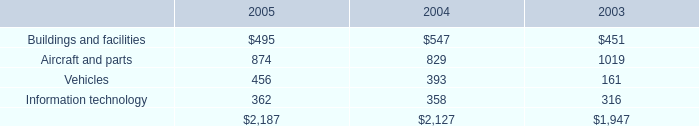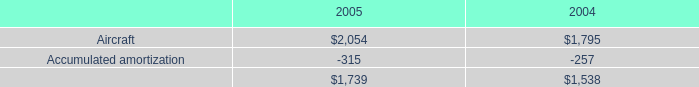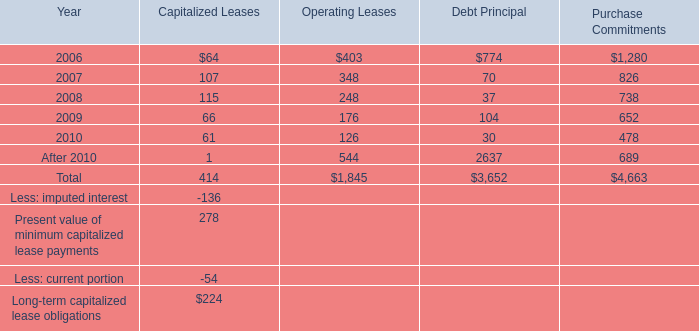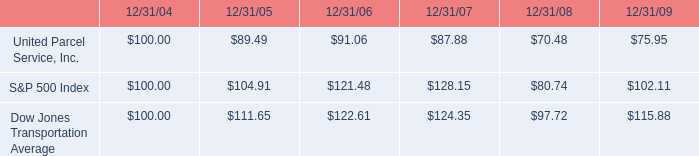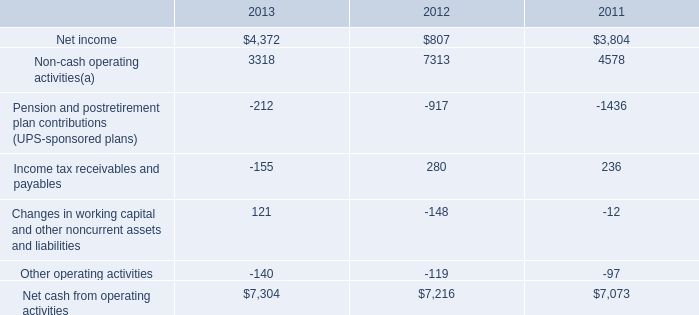what is the roi of an investment in ups in 2004 and sold in 2006? 
Computations: ((91.06 - 100) / 100)
Answer: -0.0894. 